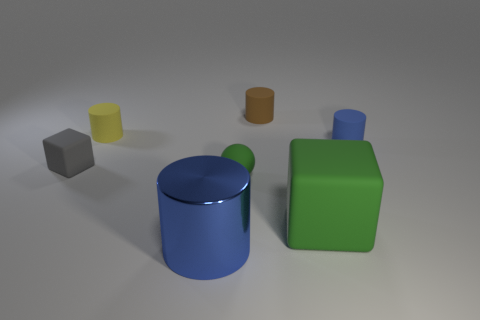What time of day or lighting conditions do you think are represented in this scene? The scene seems to be artificially illuminated rather than by natural light, which suggests an indoor setting. There's a soft shadow cast under and around the objects, indicating diffuse light sources, typical of a studio or a controlled indoor environment. Given the lack of natural lighting cues, it's difficult to infer a specific time of day from this image. 